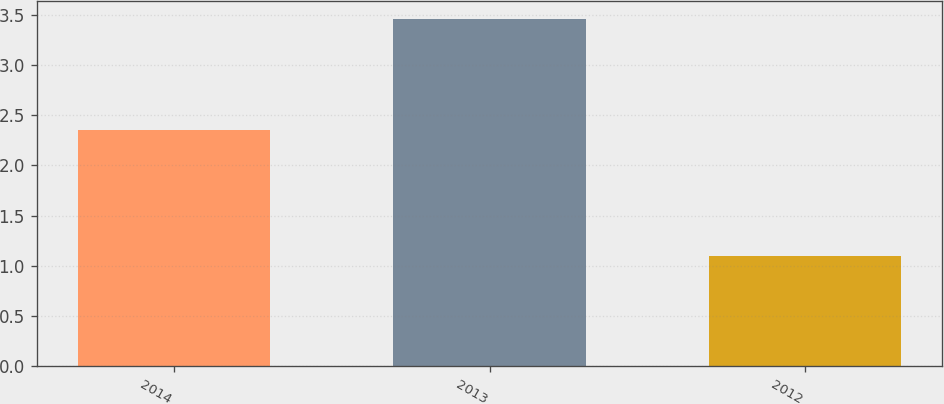Convert chart to OTSL. <chart><loc_0><loc_0><loc_500><loc_500><bar_chart><fcel>2014<fcel>2013<fcel>2012<nl><fcel>2.35<fcel>3.46<fcel>1.1<nl></chart> 